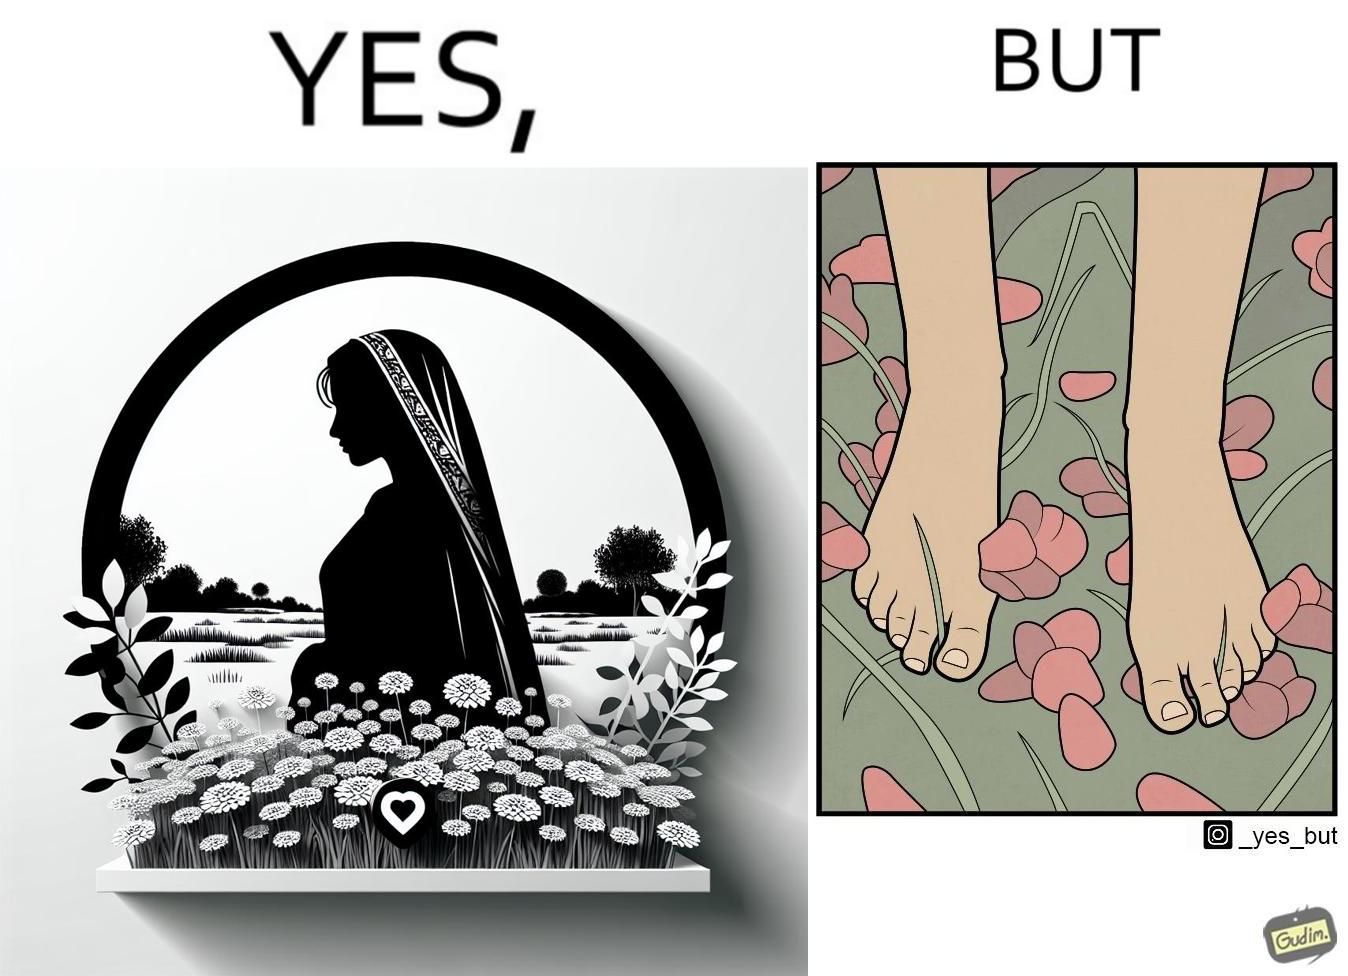Is this image satirical or non-satirical? Yes, this image is satirical. 